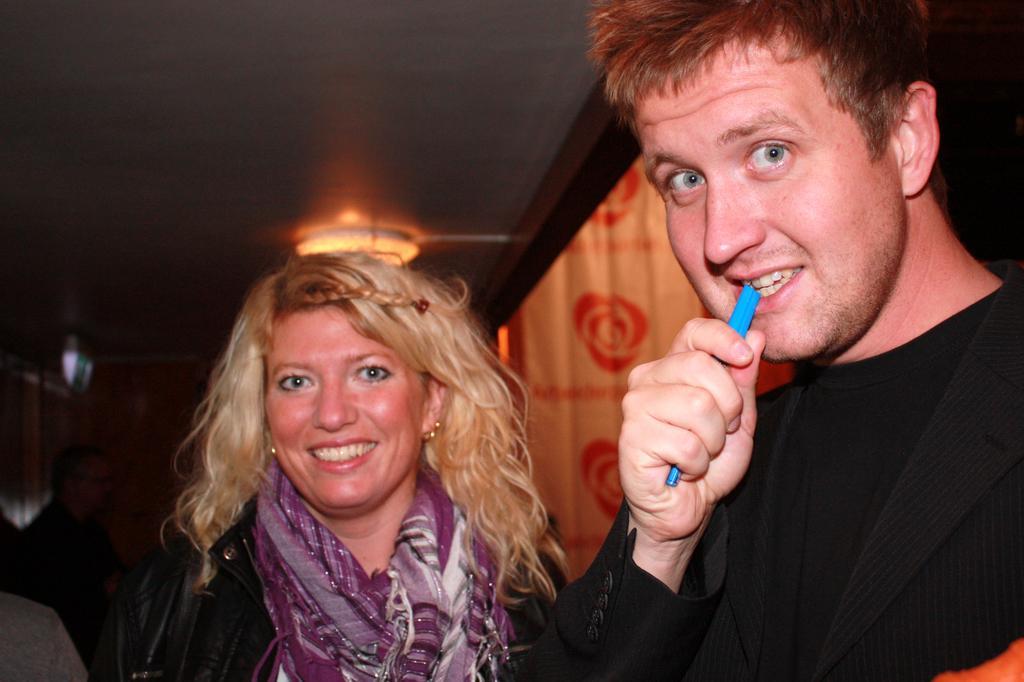Can you describe this image briefly? In the image two persons are standing and smiling. Behind them few people are standing. At the top of the image there is roof and light. 